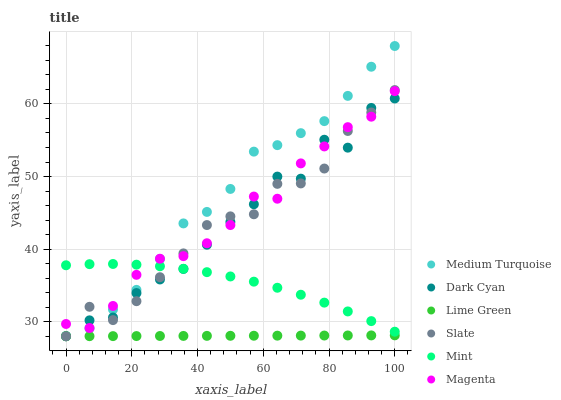Does Lime Green have the minimum area under the curve?
Answer yes or no. Yes. Does Medium Turquoise have the maximum area under the curve?
Answer yes or no. Yes. Does Slate have the minimum area under the curve?
Answer yes or no. No. Does Slate have the maximum area under the curve?
Answer yes or no. No. Is Lime Green the smoothest?
Answer yes or no. Yes. Is Dark Cyan the roughest?
Answer yes or no. Yes. Is Slate the smoothest?
Answer yes or no. No. Is Slate the roughest?
Answer yes or no. No. Does Lime Green have the lowest value?
Answer yes or no. Yes. Does Medium Turquoise have the lowest value?
Answer yes or no. No. Does Medium Turquoise have the highest value?
Answer yes or no. Yes. Does Slate have the highest value?
Answer yes or no. No. Is Lime Green less than Medium Turquoise?
Answer yes or no. Yes. Is Magenta greater than Lime Green?
Answer yes or no. Yes. Does Slate intersect Mint?
Answer yes or no. Yes. Is Slate less than Mint?
Answer yes or no. No. Is Slate greater than Mint?
Answer yes or no. No. Does Lime Green intersect Medium Turquoise?
Answer yes or no. No. 